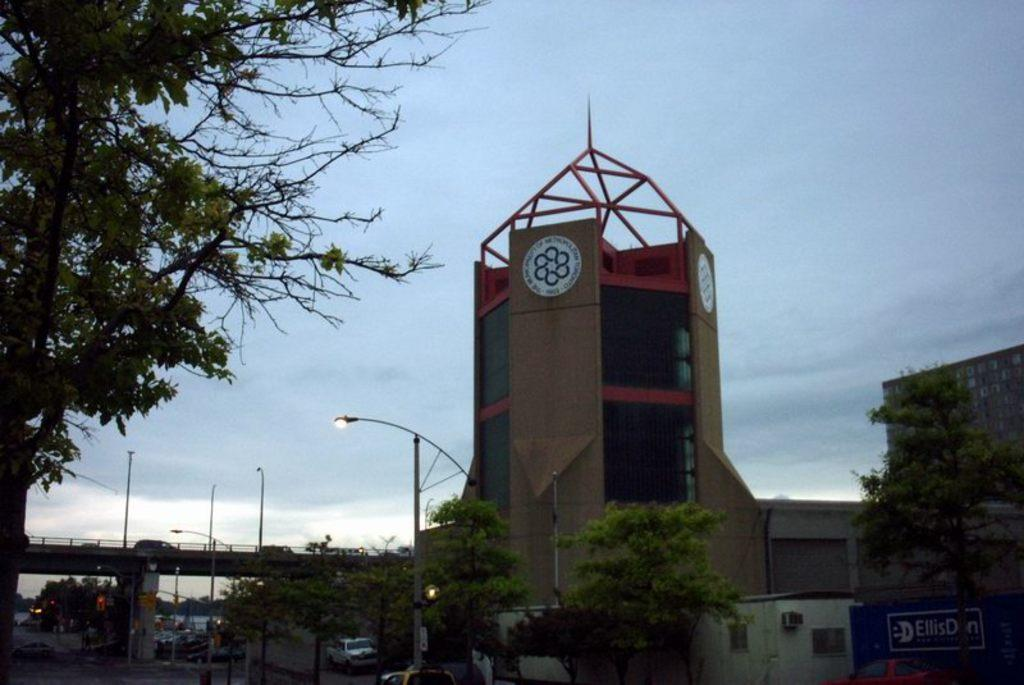What type of buildings can be seen in the image? There are buildings with glass doors in the image. What natural elements are present in the image? Trees are visible in the image. What type of infrastructure is depicted in the image? There is a flyover with vehicles in the image. What is used for illumination at night in the image? Street lights are present in the image. What mode of transportation is visible on the road in the image? There is a car on the road in the image. What part of the environment is visible in the image? The sky is visible in the image. How many committee members are visible in the image? There are no committee members present in the image. What type of boat can be seen sailing in the sky in the image? There is no boat present in the image, and the sky is visible, not a boat sailing in it. 